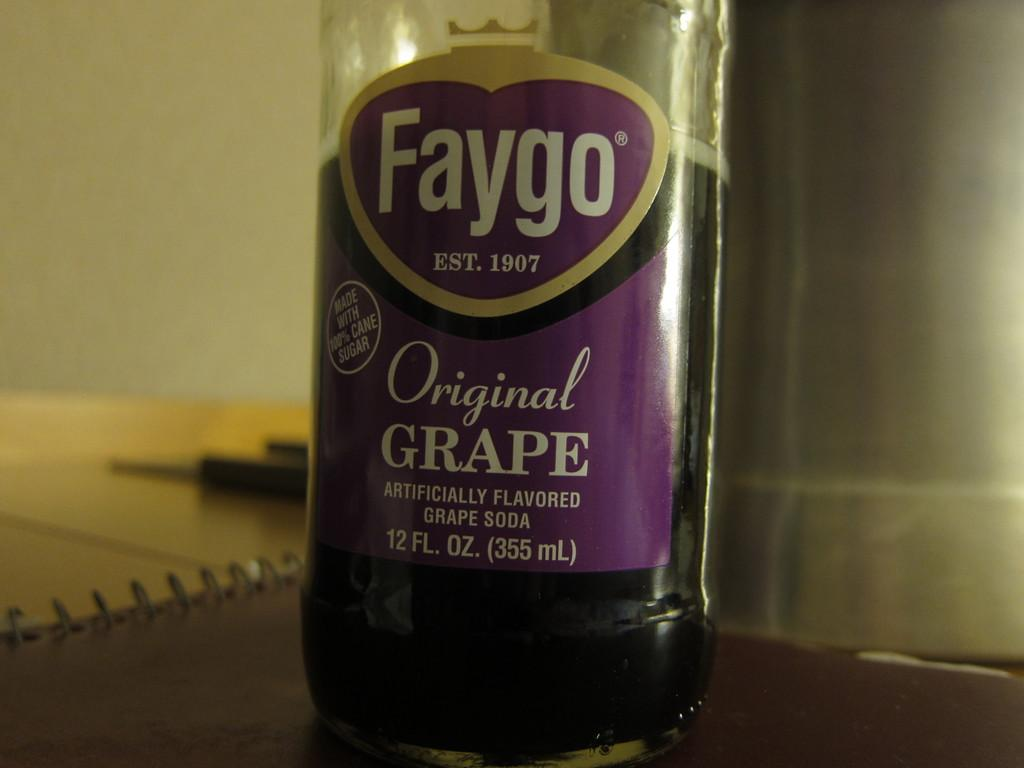What is the name of the product in the bottle in the image? The bottle is labeled as "faygo". What is inside the bottle in the image? The bottle contains liquid content. What is the bottle placed on in the image? The bottle is placed on a book. What is the color of the book in the image? The book is brown in color. What type of statement is written on the alley wall in the image? There is no alley or statement written on a wall present in the image. 